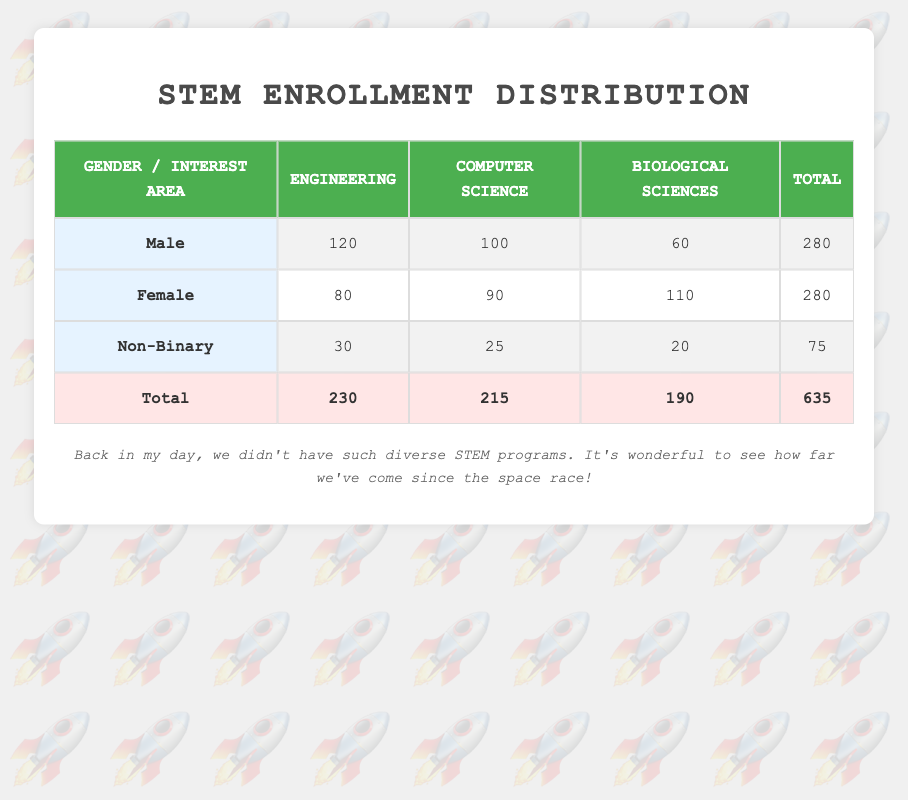What is the total enrollment for male students in STEM programs? To find the total enrollment for male students, we look at the "Total" column in the row for "Male." The total for male students is 280.
Answer: 280 What is the enrollment count for female students interested in Computer Science? Looking at the "Female" row under "Computer Science," the enrollment count is 90.
Answer: 90 Is the enrollment in the Biological Sciences higher for females than for males? We compare the numbers from the "Biological Sciences" column: females have 110 and males have 60. Since 110 is greater than 60, the statement is true.
Answer: Yes What is the difference in enrollment between male and non-binary students in Engineering? For males in Engineering, the enrollment is 120, while for non-binary students it is 30. The difference is calculated as 120 - 30 = 90.
Answer: 90 What percentage of total STEM enrollment is represented by non-binary students? The total STEM enrollment is 635, and the total for non-binary students is 75. We calculate the percentage as (75 / 635) * 100, which is approximately 11.81%.
Answer: 11.81% What is the total enrollment in the Engineering field across all gender groups? To find the total enrollment in Engineering, we add the enrollment for all genders: 120 (male) + 80 (female) + 30 (non-binary) = 230.
Answer: 230 Are there more students enrolled in Computer Science than in Engineering? We compare the totals: Computer Science has 215 and Engineering has 230. Since 215 is less than 230, the statement is false.
Answer: No What is the average enrollment count for students interested in Biological Sciences? We have three groups: males (60), females (110), and non-binary (20). The total count is 60 + 110 + 20 = 190. Since there are 3 groups, the average is 190 / 3, which is approximately 63.33.
Answer: 63.33 Which gender has the least enrollment in Computer Science? Examining the Computer Science column, males have 100, females have 90, and non-binary have 25. Non-binary students have the least with 25.
Answer: Non-Binary 